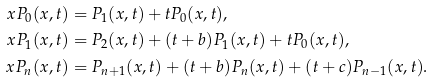Convert formula to latex. <formula><loc_0><loc_0><loc_500><loc_500>x P _ { 0 } ( x , t ) & = P _ { 1 } ( x , t ) + t P _ { 0 } ( x , t ) , \\ x P _ { 1 } ( x , t ) & = P _ { 2 } ( x , t ) + ( t + b ) P _ { 1 } ( x , t ) + t P _ { 0 } ( x , t ) , \\ x P _ { n } ( x , t ) & = P _ { n + 1 } ( x , t ) + ( t + b ) P _ { n } ( x , t ) + ( t + c ) P _ { n - 1 } ( x , t ) .</formula> 